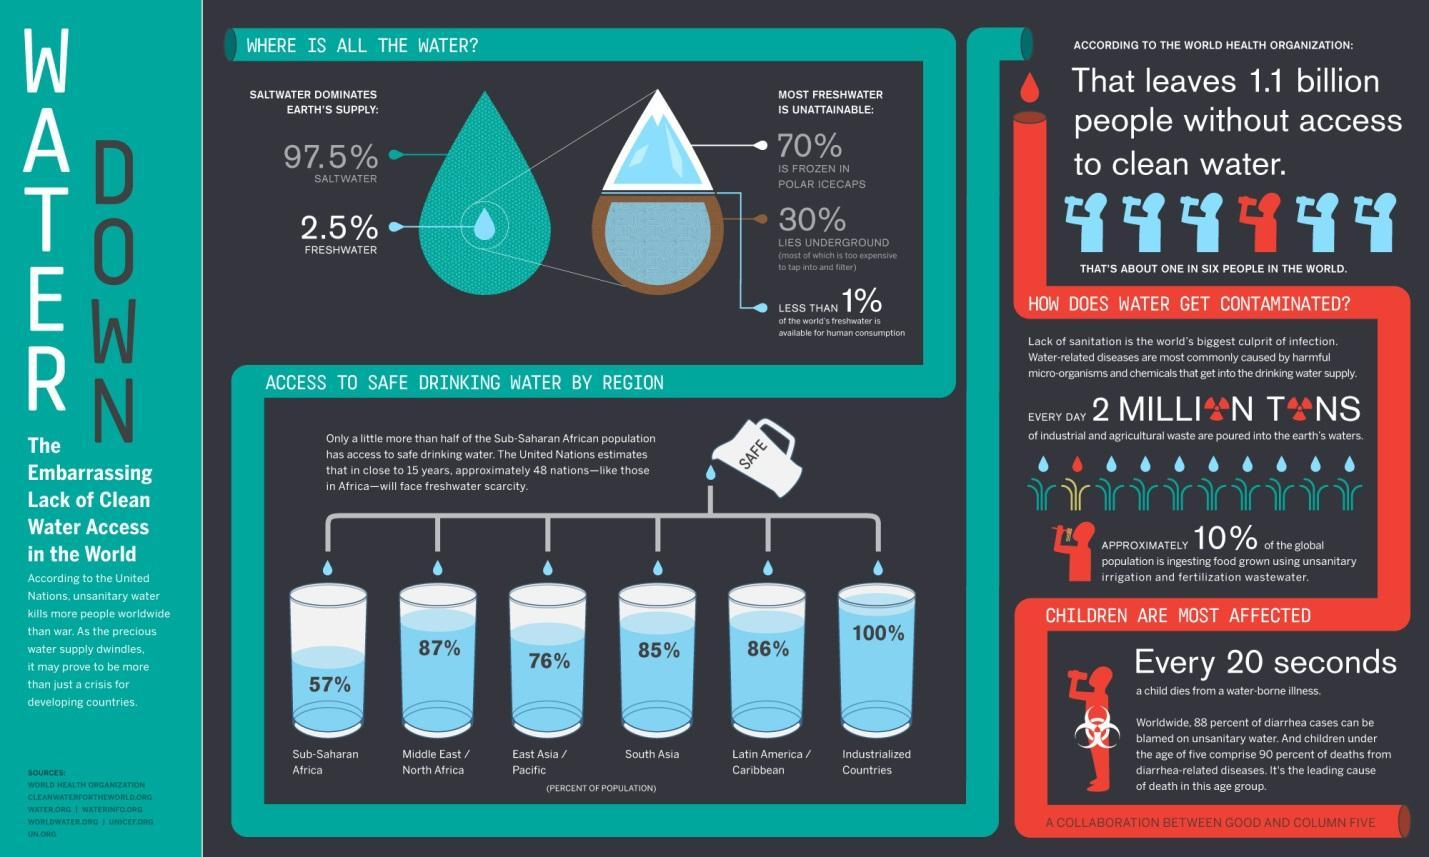What percentage of the South Asian population has access to safe drinking water?
Answer the question with a short phrase. 85% What percentage of the earth's water is fresh? 2.5% What percentage of the Middle East/North African population has access to safe drinking water? 87% Where is about 30% of earth's freshwater found? UNDERGROUND What percentage of water on the earth's surface is saline? 97.5% 